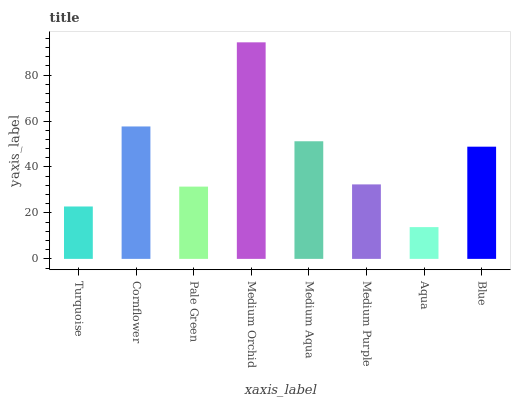Is Aqua the minimum?
Answer yes or no. Yes. Is Medium Orchid the maximum?
Answer yes or no. Yes. Is Cornflower the minimum?
Answer yes or no. No. Is Cornflower the maximum?
Answer yes or no. No. Is Cornflower greater than Turquoise?
Answer yes or no. Yes. Is Turquoise less than Cornflower?
Answer yes or no. Yes. Is Turquoise greater than Cornflower?
Answer yes or no. No. Is Cornflower less than Turquoise?
Answer yes or no. No. Is Blue the high median?
Answer yes or no. Yes. Is Medium Purple the low median?
Answer yes or no. Yes. Is Medium Orchid the high median?
Answer yes or no. No. Is Turquoise the low median?
Answer yes or no. No. 